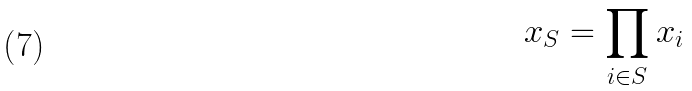<formula> <loc_0><loc_0><loc_500><loc_500>x _ { S } = \prod _ { i \in S } x _ { i }</formula> 